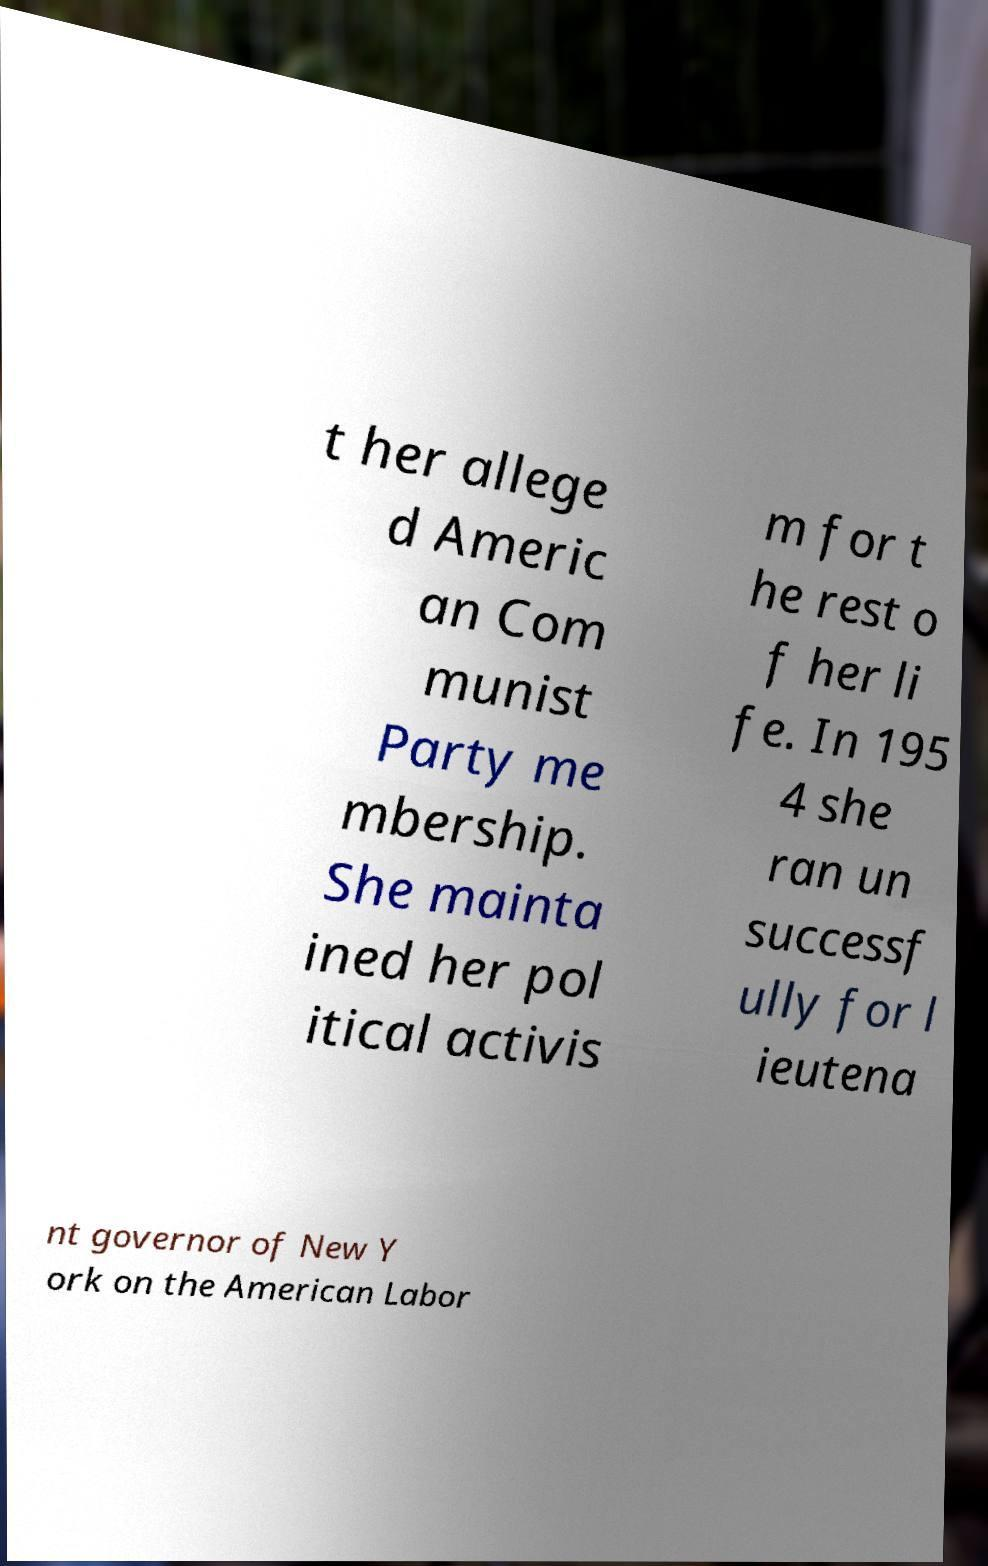Please identify and transcribe the text found in this image. t her allege d Americ an Com munist Party me mbership. She mainta ined her pol itical activis m for t he rest o f her li fe. In 195 4 she ran un successf ully for l ieutena nt governor of New Y ork on the American Labor 